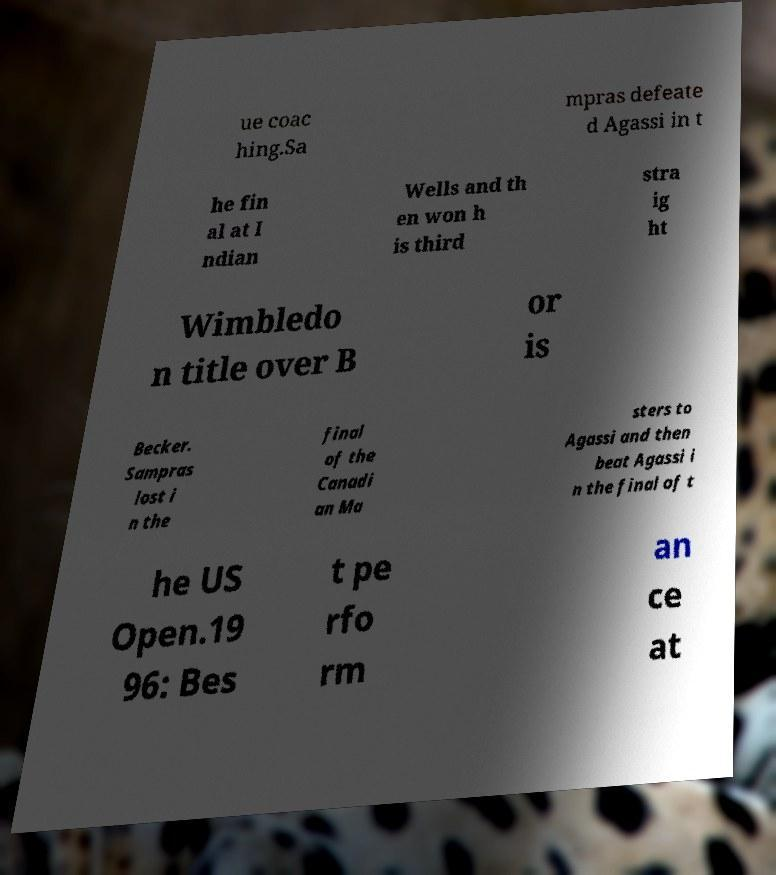There's text embedded in this image that I need extracted. Can you transcribe it verbatim? ue coac hing.Sa mpras defeate d Agassi in t he fin al at I ndian Wells and th en won h is third stra ig ht Wimbledo n title over B or is Becker. Sampras lost i n the final of the Canadi an Ma sters to Agassi and then beat Agassi i n the final of t he US Open.19 96: Bes t pe rfo rm an ce at 